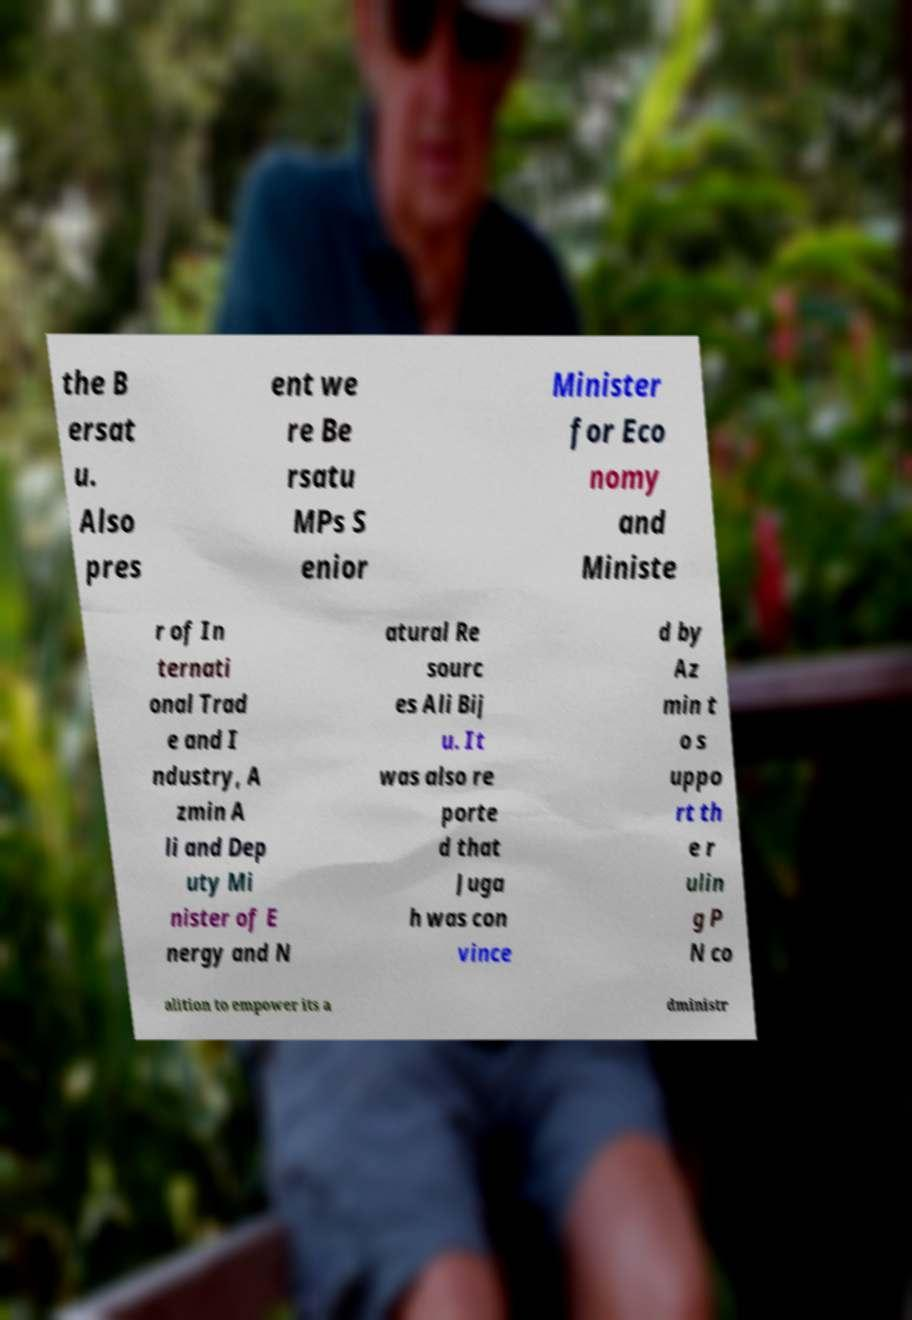There's text embedded in this image that I need extracted. Can you transcribe it verbatim? the B ersat u. Also pres ent we re Be rsatu MPs S enior Minister for Eco nomy and Ministe r of In ternati onal Trad e and I ndustry, A zmin A li and Dep uty Mi nister of E nergy and N atural Re sourc es Ali Bij u. It was also re porte d that Juga h was con vince d by Az min t o s uppo rt th e r ulin g P N co alition to empower its a dministr 